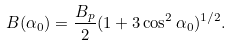<formula> <loc_0><loc_0><loc_500><loc_500>B ( \alpha _ { 0 } ) = \frac { B _ { p } } { 2 } ( 1 + 3 \cos ^ { 2 } \alpha _ { 0 } ) ^ { 1 / 2 } .</formula> 